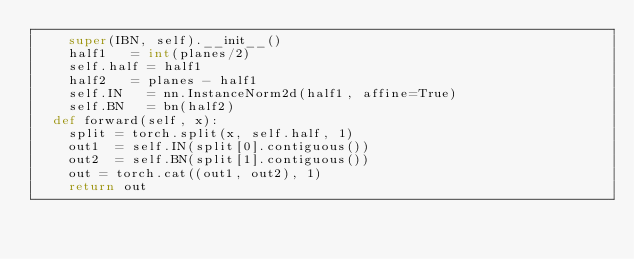<code> <loc_0><loc_0><loc_500><loc_500><_Python_>		super(IBN, self).__init__()
		half1		= int(planes/2)
		self.half	= half1
		half2		= planes - half1
		self.IN		= nn.InstanceNorm2d(half1, affine=True)
		self.BN		= bn(half2)
	def forward(self, x):
		split	= torch.split(x, self.half, 1)
		out1	= self.IN(split[0].contiguous())
		out2	= self.BN(split[1].contiguous())
		out	= torch.cat((out1, out2), 1)
		return out
</code> 